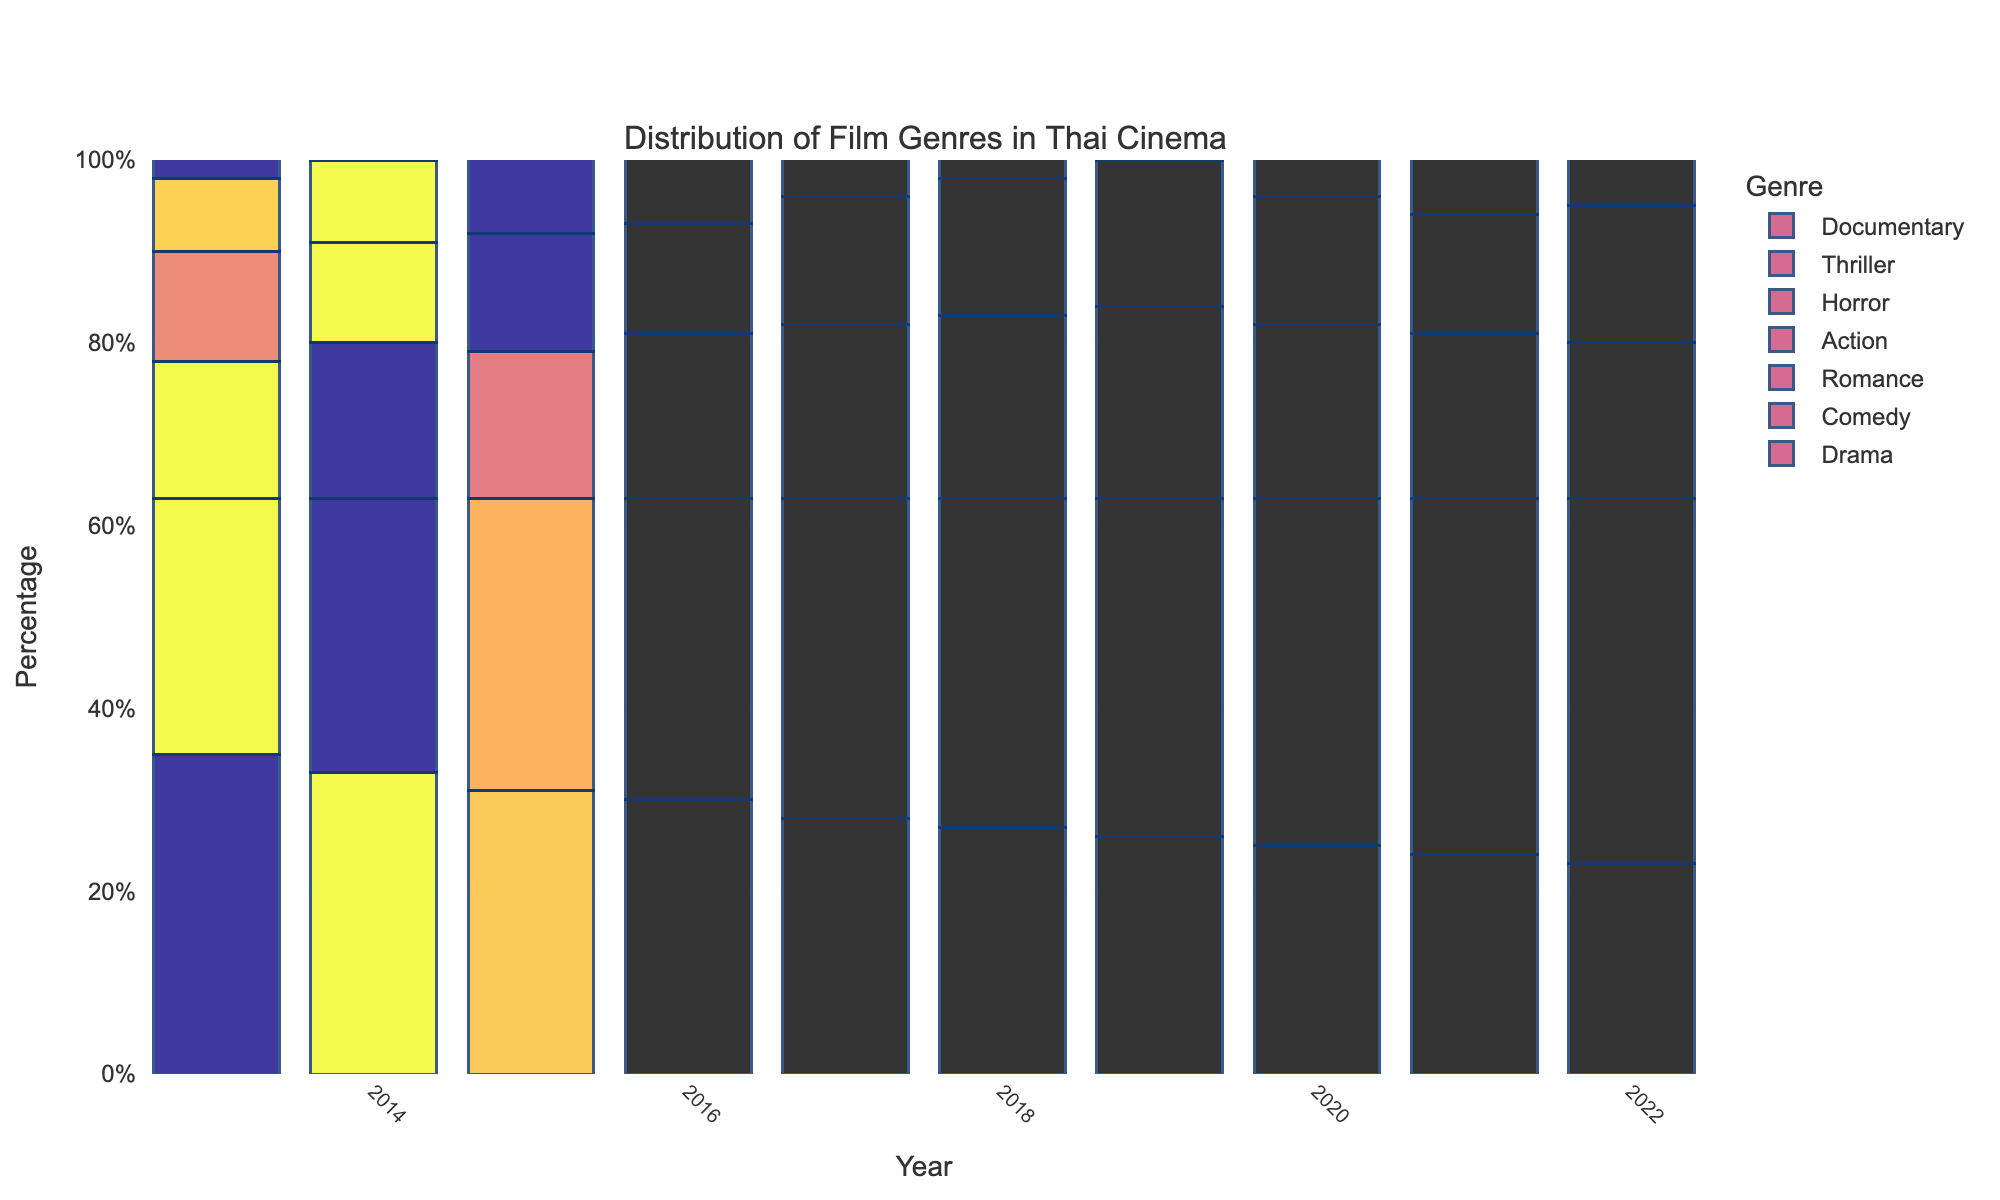What's the most popular genre in 2022? By looking at the bars in the figure, the tallest bar for 2022 corresponds to the Comedy genre.
Answer: Comedy Which genre shows a consistent increase in number over the years? By examining the heights of the bars over the years for each genre, the Comedy genre shows a consistent increase in height from 2013 to 2022.
Answer: Comedy What is the combined count for Drama and Documentary genres in 2019? The height of the Drama bar in 2019 is 26 and that of the Documentary bar is 5. Adding them together gives 26 + 5.
Answer: 31 Which genre experienced the largest increase in number from 2013 to 2022? Compare the difference in height between 2013 and 2022 for each genre. The largest increase is seen in the Comedy genre, which increased from 28 to 40, a difference of 12.
Answer: Comedy What trend do you notice for the Horror genre from 2013 to 2022? By observing the height of the bars for the Horror genre from 2013 to 2022, the trend is an overall gradual increase, from 8 in 2013 to 16 in 2022.
Answer: Gradual Increase Which year had the highest number of Action films? By looking at the height of the bars for the Action genre across all years, the tallest bar is in 2022 with a count of 15.
Answer: 2022 What’s the difference in the number of Thriller films between 2015 and 2021? The height of the Thriller bar in 2015 is 6 and in 2021 is 9. The difference is 9 - 6.
Answer: 3 Among Drama, Comedy, and Romance, which had the least number of films in 2020? In 2020, the heights of bars for Drama, Comedy, and Romance are 25, 38, and 19 respectively. Drama had the least number.
Answer: Drama How did the number of Documentary films change from 2013 to 2022? Observing the heights of the Documentary bars in 2013 and 2022, there is an increase from 2 to 8.
Answer: Increased by 6 Which two genres had similar counts in 2017? By comparing the heights of the bars in 2017, Action and Horror both had similar counts with 14 and 10 respectively.
Answer: Action and Horror 